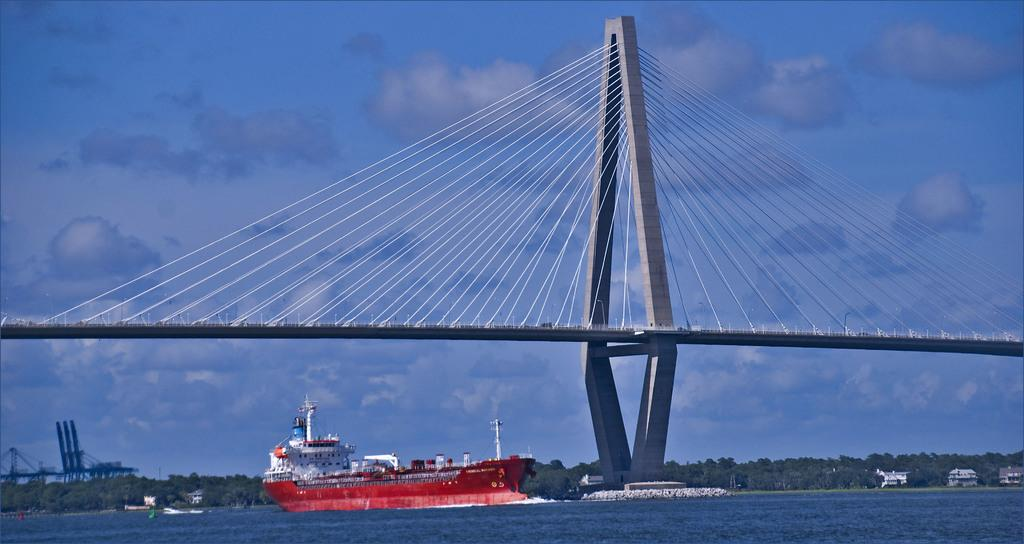What is the main subject in the water in the image? There is a ship in the water in the image. What structure can be seen crossing over the water? There is a bridge in the image. What type of man-made structures are visible in the image? There are many buildings in the image. What type of natural elements can be seen in the image? There are trees in the image. How would you describe the weather based on the sky in the image? The sky is cloudy in the image. What type of rice is being cooked in the image? There is no rice present in the image. How does the idea breathe in the image? There is no idea or breathing depicted in the image; it features a ship, a bridge, buildings, trees, and a cloudy sky. 